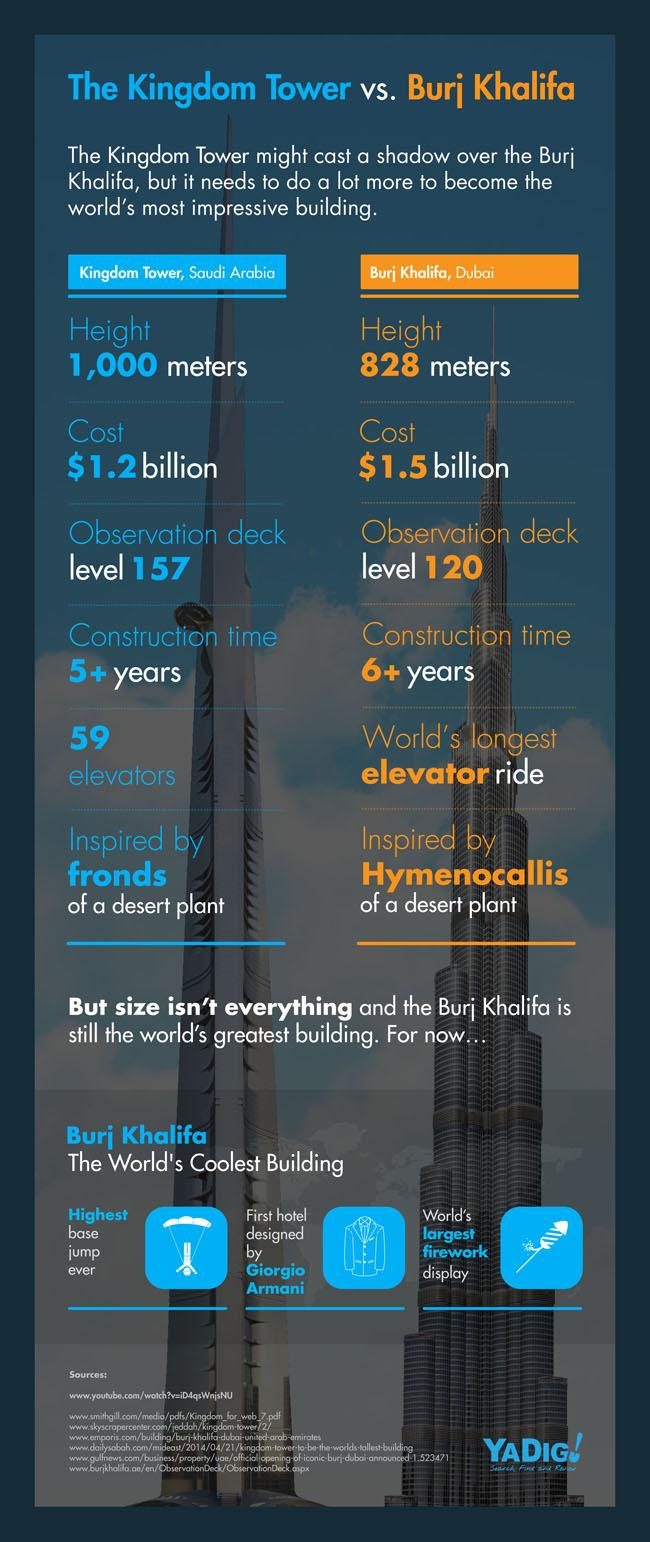Highlight a few significant elements in this photo. The construction of Burj Khalifa took approximately 6 years to complete. The construction cost of the Burj Khalifa was approximately 1.5 billion. The Kingdom Tower's design was inspired by the fronds of a desert plant and is considered a notable example of futuristic architecture. The construction of Kingdom Tower took an indefinite number of years to complete. The observation deck in Kingdom Tower is located at level 157. 